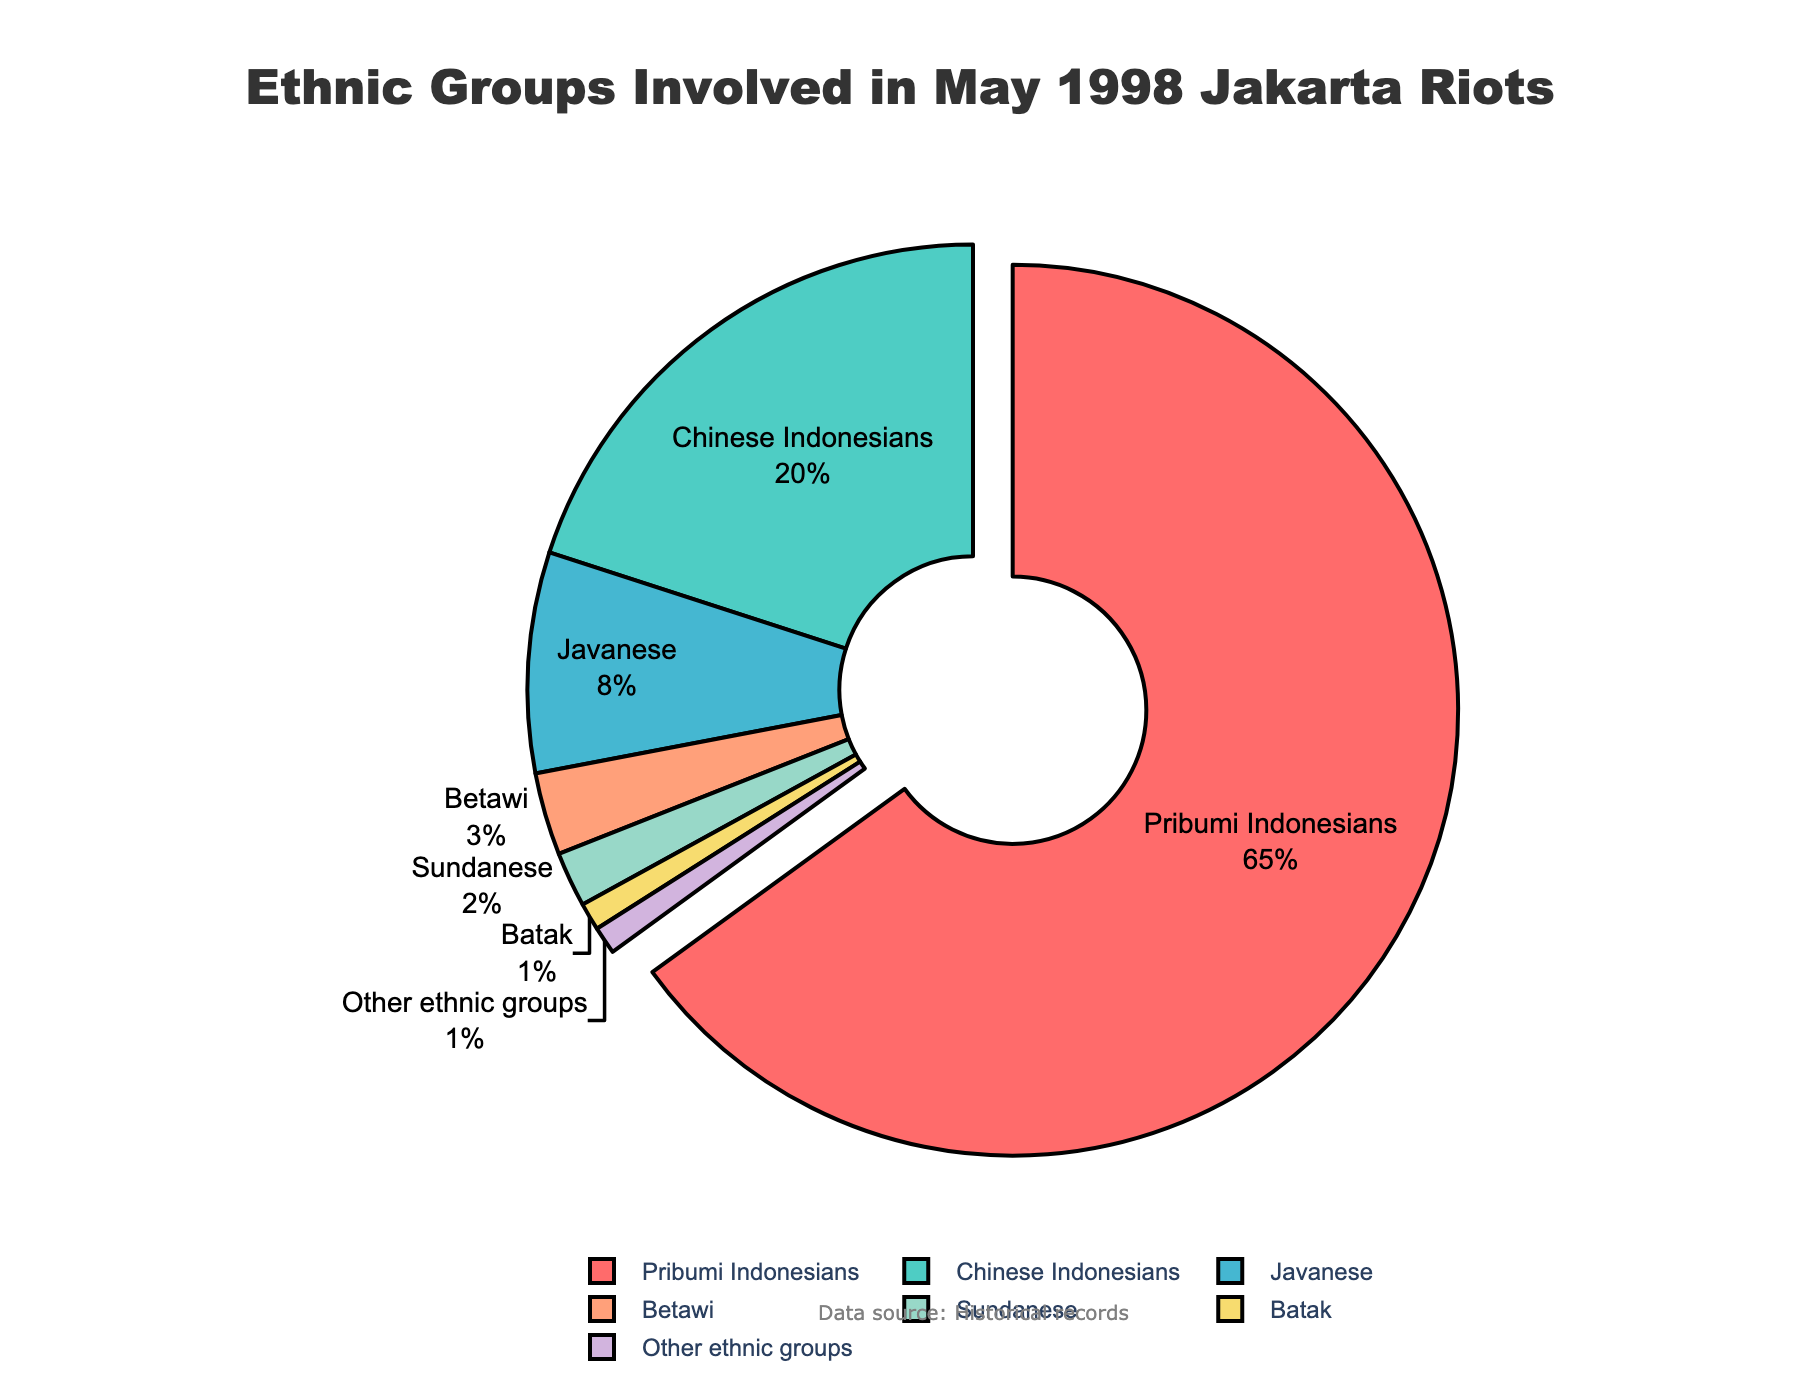What is the largest ethnic group involved in the riots? The largest ethnic group is the one with the highest percentage in the pie chart. Pribumi Indonesians have 65%, which is the largest percentage.
Answer: Pribumi Indonesians Which ethnic group has the smallest involvement in the riots? The smallest ethnic group is the one with the lowest percentage in the pie chart. Both Batak and Other ethnic groups have the smallest percentage at 1%.
Answer: Batak and Other ethnic groups What proportion of ethnic groups were not Pribumi Indonesians, Chinese Indonesians, or Javanese? To find the proportion, sum the percentages of Betawi, Sundanese, Batak, and Other ethnic groups: 3% + 2% + 1% + 1% = 7%.
Answer: 7% Compare the percentage of Chinese Indonesians to that of Javanese. Which is larger and by how much? First, note the percentages: Chinese Indonesians have 20% and Javanese have 8%. The difference is 20% - 8% = 12%. Therefore, Chinese Indonesians have a larger involvement, larger by 12%.
Answer: Chinese Indonesians, larger by 12% What is the total percentage of Sundanese and Batak involved in the riots? Sum the percentages of Sundanese and Batak: 2% + 1% = 3%.
Answer: 3% What percentage is labeled on the largest pulled-out segment of the pie chart? The chart pulls out the segment for Pribumi Indonesians, and their percentage is 65%.
Answer: 65% Between Betawi and Sundanese, which group has a higher percentage and by what amount? Betawi have 3% and Sundanese have 2%. The difference is 3% - 2% = 1%. Therefore, Betawi have a higher percentage by 1%.
Answer: Betawi, higher by 1% What is the average percentage of involvement for the groups Betawi, Sundanese, and Batak? Sum the percentages of Betawi, Sundanese, and Batak: 3% + 2% + 1% = 6%. The number of groups is 3, so the average is 6% / 3 = 2%.
Answer: 2% Sum the percentage of Javanese and Betawi involvement in the riots. How does it compare to the percentage of Chinese Indonesians? Sum the percentages of Javanese and Betawi: 8% + 3% = 11%. Compare this to Chinese Indonesians with 20%. Chinese Indonesians' percentage (20%) is greater than the combined (11%) by 20% - 11% = 9%.
Answer: Chinese Indonesians, greater by 9% What is the percentage of ethnic groups labeled with two colors closest to each other on the color wheel used in the chart? The colors for Pribumi Indonesians and Javanese segments are notably distinct but on the color wheel: red (#FF6B6B) and orange (#FFA07A), respectively. Sum their percentages: 65% + 8% = 73%.
Answer: 73% 